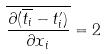Convert formula to latex. <formula><loc_0><loc_0><loc_500><loc_500>\overline { \frac { \partial ( \overline { t _ { i } } - t _ { i } ^ { \prime } ) } { \partial x _ { i } } } = 2</formula> 